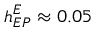Convert formula to latex. <formula><loc_0><loc_0><loc_500><loc_500>h _ { E P } ^ { E } \approx 0 . 0 5</formula> 